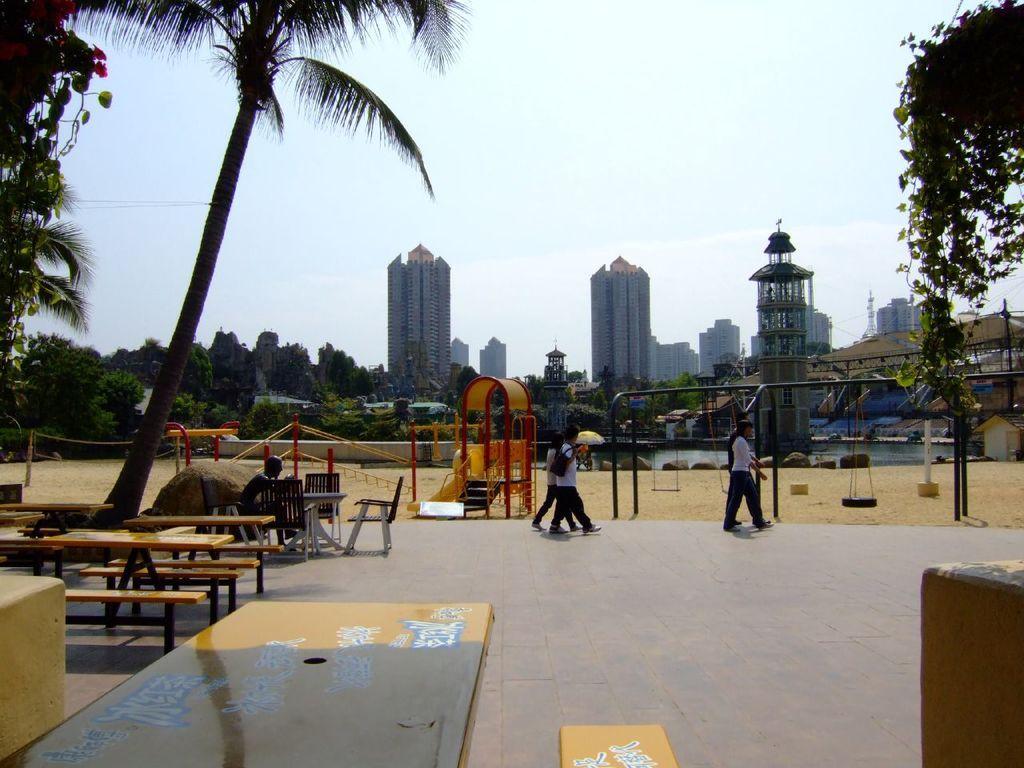Please provide a concise description of this image. This image is inside of the city. At the back there are buildings, at the left and at the right there are trees. There are people in the image. At the bottom there is a water, at the left there are benches, tables and chairs, at the top there is sky. 